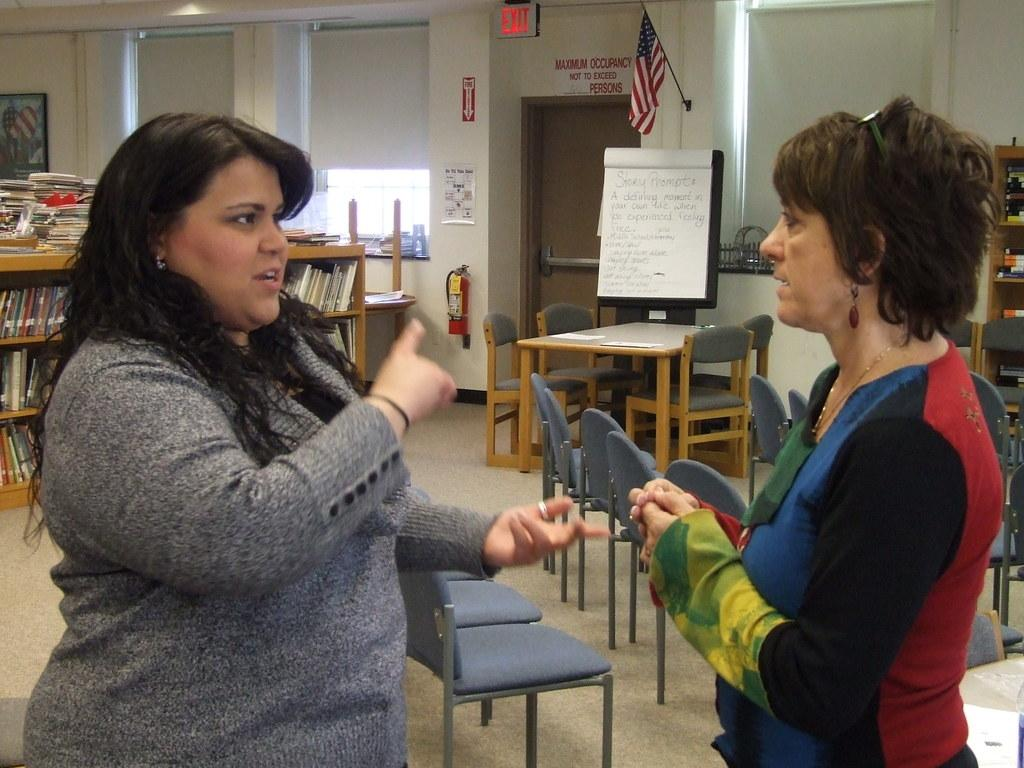How many women are present in the image? There are two women standing in the image. What can be seen in the background of the image? There is a door, a flag, a paper board, a wall, empty chairs, a table, and a books rack in the background of the image. What type of oranges are being used as decorations on the table in the image? There are no oranges present in the image; the table and other objects mentioned are the only visible items. 